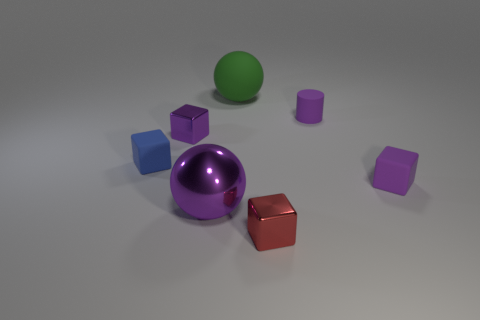Do the green rubber object and the large purple metallic thing have the same shape? yes 